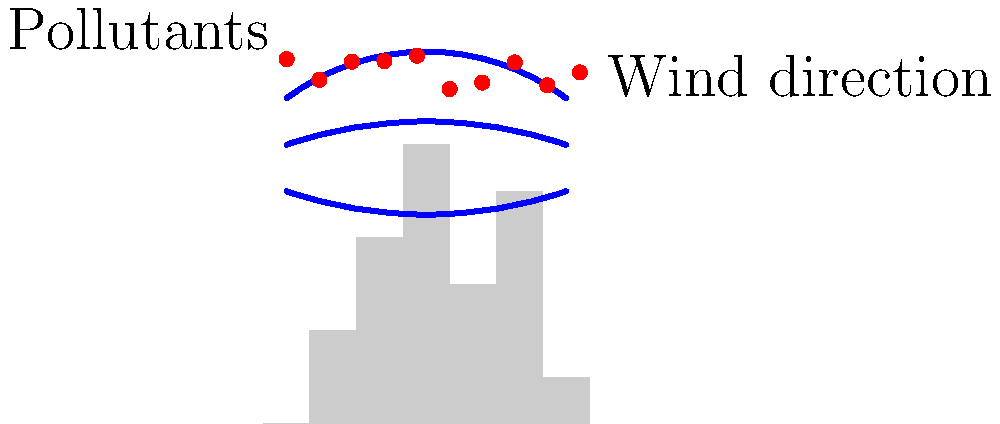In the urban environment depicted above, which aerodynamic phenomenon is most likely responsible for the concentration of pollutants near the ground level, and how does it affect the dispersion of air pollutants in relation to building heights? To answer this question, we need to consider several aerodynamic principles:

1. Urban canopy layer: The space between buildings where air circulation is complex and often restricted.

2. Wind flow patterns: In urban areas, tall buildings create a complex wind field, altering the natural flow of air.

3. Urban heat island effect: Cities tend to be warmer than surrounding areas, affecting air movement.

4. Turbulence: Buildings create turbulent eddies, which can trap pollutants.

5. Venturi effect: Wind speeds up as it's forced between buildings.

The phenomenon most responsible for pollutant concentration near the ground is likely the "urban street canyon effect." This occurs when:

a) Tall buildings form "canyons" that trap air and pollutants.
b) Wind flow over buildings creates a recirculation vortex within the canyon.
c) This vortex traps and concentrates pollutants at street level.

The dispersion of pollutants is affected by building heights as follows:

1. Taller buildings create stronger vortices, potentially trapping more pollutants.
2. The aspect ratio (height/width) of the street canyon influences air exchange:
   - Higher ratios (narrow streets, tall buildings) reduce vertical mixing.
   - Lower ratios allow for better ventilation.
3. Building arrangement affects wind patterns:
   - Staggered arrangements may improve dispersion.
   - Uniform heights can create a "skimming flow" above rooftops, reducing street-level air exchange.

In summary, the urban street canyon effect, created by the interaction of building geometries and wind patterns, is the primary phenomenon responsible for near-ground pollutant concentration in urban environments.
Answer: Urban street canyon effect 